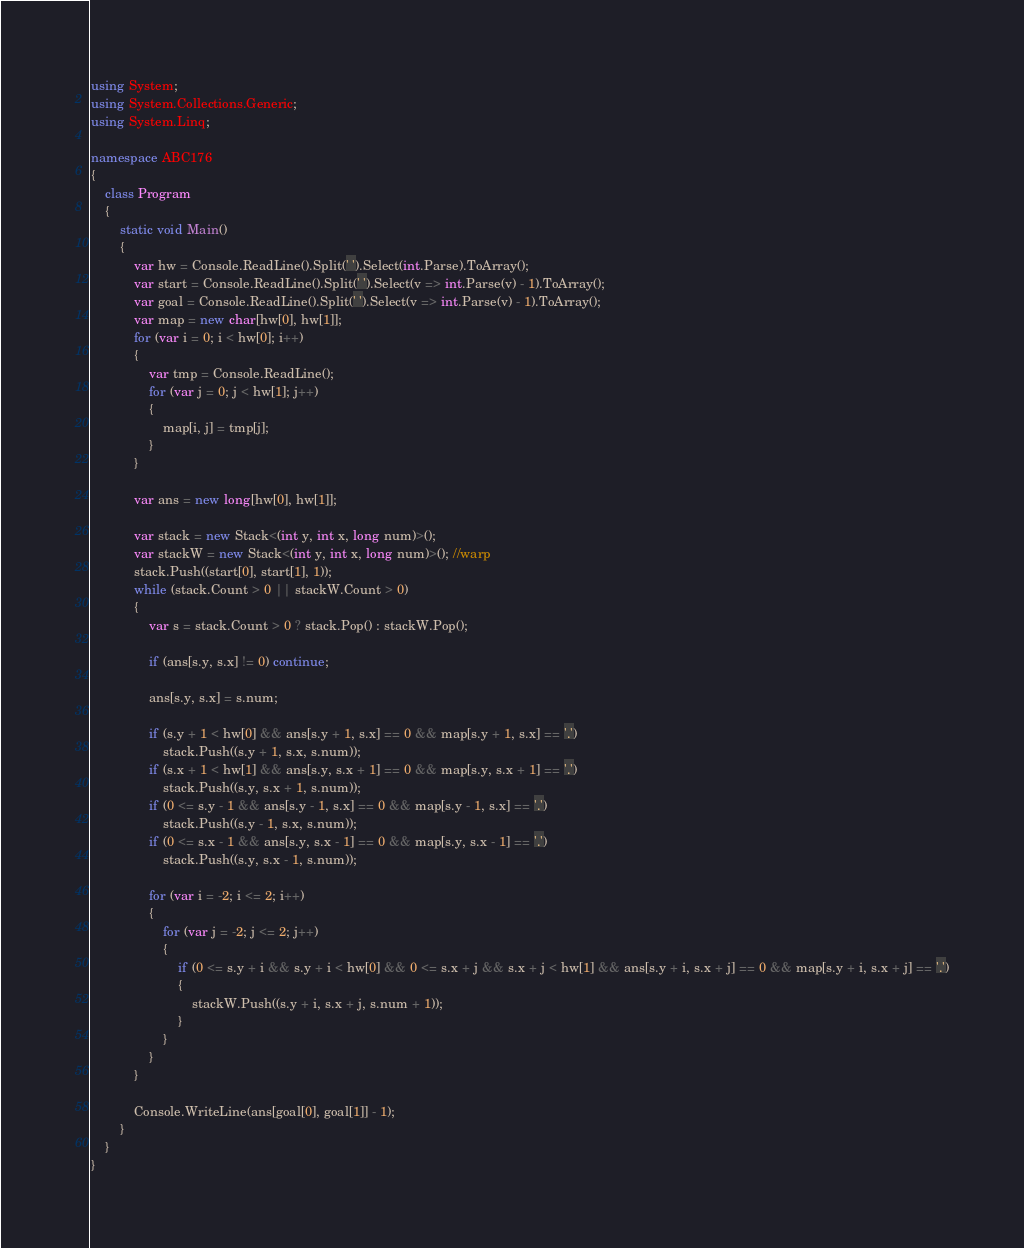<code> <loc_0><loc_0><loc_500><loc_500><_C#_>using System;
using System.Collections.Generic;
using System.Linq;

namespace ABC176
{
    class Program
    {
        static void Main()
        {
            var hw = Console.ReadLine().Split(' ').Select(int.Parse).ToArray();
            var start = Console.ReadLine().Split(' ').Select(v => int.Parse(v) - 1).ToArray();
            var goal = Console.ReadLine().Split(' ').Select(v => int.Parse(v) - 1).ToArray();
            var map = new char[hw[0], hw[1]];
            for (var i = 0; i < hw[0]; i++)
            {
                var tmp = Console.ReadLine();
                for (var j = 0; j < hw[1]; j++)
                {
                    map[i, j] = tmp[j];
                }
            }

            var ans = new long[hw[0], hw[1]];

            var stack = new Stack<(int y, int x, long num)>();
            var stackW = new Stack<(int y, int x, long num)>(); //warp
            stack.Push((start[0], start[1], 1));
            while (stack.Count > 0 || stackW.Count > 0)
            {
                var s = stack.Count > 0 ? stack.Pop() : stackW.Pop();

                if (ans[s.y, s.x] != 0) continue;

                ans[s.y, s.x] = s.num;

                if (s.y + 1 < hw[0] && ans[s.y + 1, s.x] == 0 && map[s.y + 1, s.x] == '.')
                    stack.Push((s.y + 1, s.x, s.num));
                if (s.x + 1 < hw[1] && ans[s.y, s.x + 1] == 0 && map[s.y, s.x + 1] == '.')
                    stack.Push((s.y, s.x + 1, s.num));
                if (0 <= s.y - 1 && ans[s.y - 1, s.x] == 0 && map[s.y - 1, s.x] == '.')
                    stack.Push((s.y - 1, s.x, s.num));
                if (0 <= s.x - 1 && ans[s.y, s.x - 1] == 0 && map[s.y, s.x - 1] == '.')
                    stack.Push((s.y, s.x - 1, s.num));

                for (var i = -2; i <= 2; i++)
                {
                    for (var j = -2; j <= 2; j++)
                    {
                        if (0 <= s.y + i && s.y + i < hw[0] && 0 <= s.x + j && s.x + j < hw[1] && ans[s.y + i, s.x + j] == 0 && map[s.y + i, s.x + j] == '.')
                        {
                            stackW.Push((s.y + i, s.x + j, s.num + 1));
                        }
                    }
                }
            }

            Console.WriteLine(ans[goal[0], goal[1]] - 1);
        }
    }
}</code> 